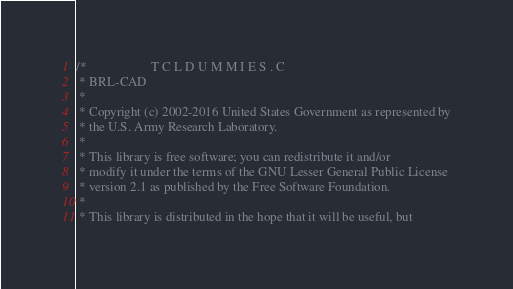<code> <loc_0><loc_0><loc_500><loc_500><_C_>/*                    T C L D U M M I E S . C
 * BRL-CAD
 *
 * Copyright (c) 2002-2016 United States Government as represented by
 * the U.S. Army Research Laboratory.
 *
 * This library is free software; you can redistribute it and/or
 * modify it under the terms of the GNU Lesser General Public License
 * version 2.1 as published by the Free Software Foundation.
 *
 * This library is distributed in the hope that it will be useful, but</code> 